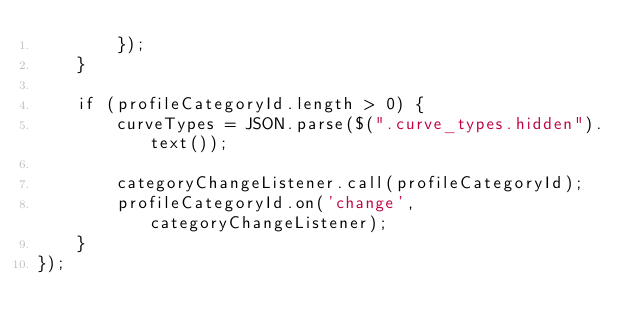Convert code to text. <code><loc_0><loc_0><loc_500><loc_500><_JavaScript_>        });
    }

    if (profileCategoryId.length > 0) {
        curveTypes = JSON.parse($(".curve_types.hidden").text());

        categoryChangeListener.call(profileCategoryId);
        profileCategoryId.on('change', categoryChangeListener);
    }
});
</code> 